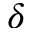Convert formula to latex. <formula><loc_0><loc_0><loc_500><loc_500>\delta</formula> 